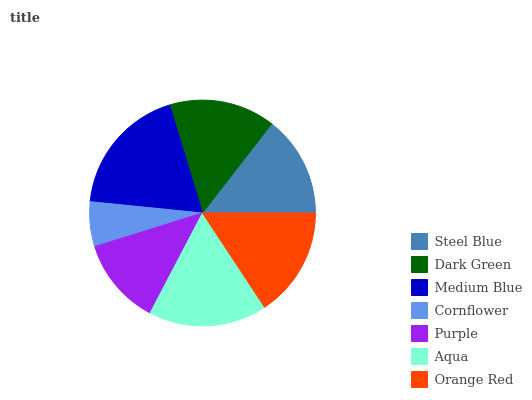Is Cornflower the minimum?
Answer yes or no. Yes. Is Medium Blue the maximum?
Answer yes or no. Yes. Is Dark Green the minimum?
Answer yes or no. No. Is Dark Green the maximum?
Answer yes or no. No. Is Dark Green greater than Steel Blue?
Answer yes or no. Yes. Is Steel Blue less than Dark Green?
Answer yes or no. Yes. Is Steel Blue greater than Dark Green?
Answer yes or no. No. Is Dark Green less than Steel Blue?
Answer yes or no. No. Is Dark Green the high median?
Answer yes or no. Yes. Is Dark Green the low median?
Answer yes or no. Yes. Is Steel Blue the high median?
Answer yes or no. No. Is Orange Red the low median?
Answer yes or no. No. 